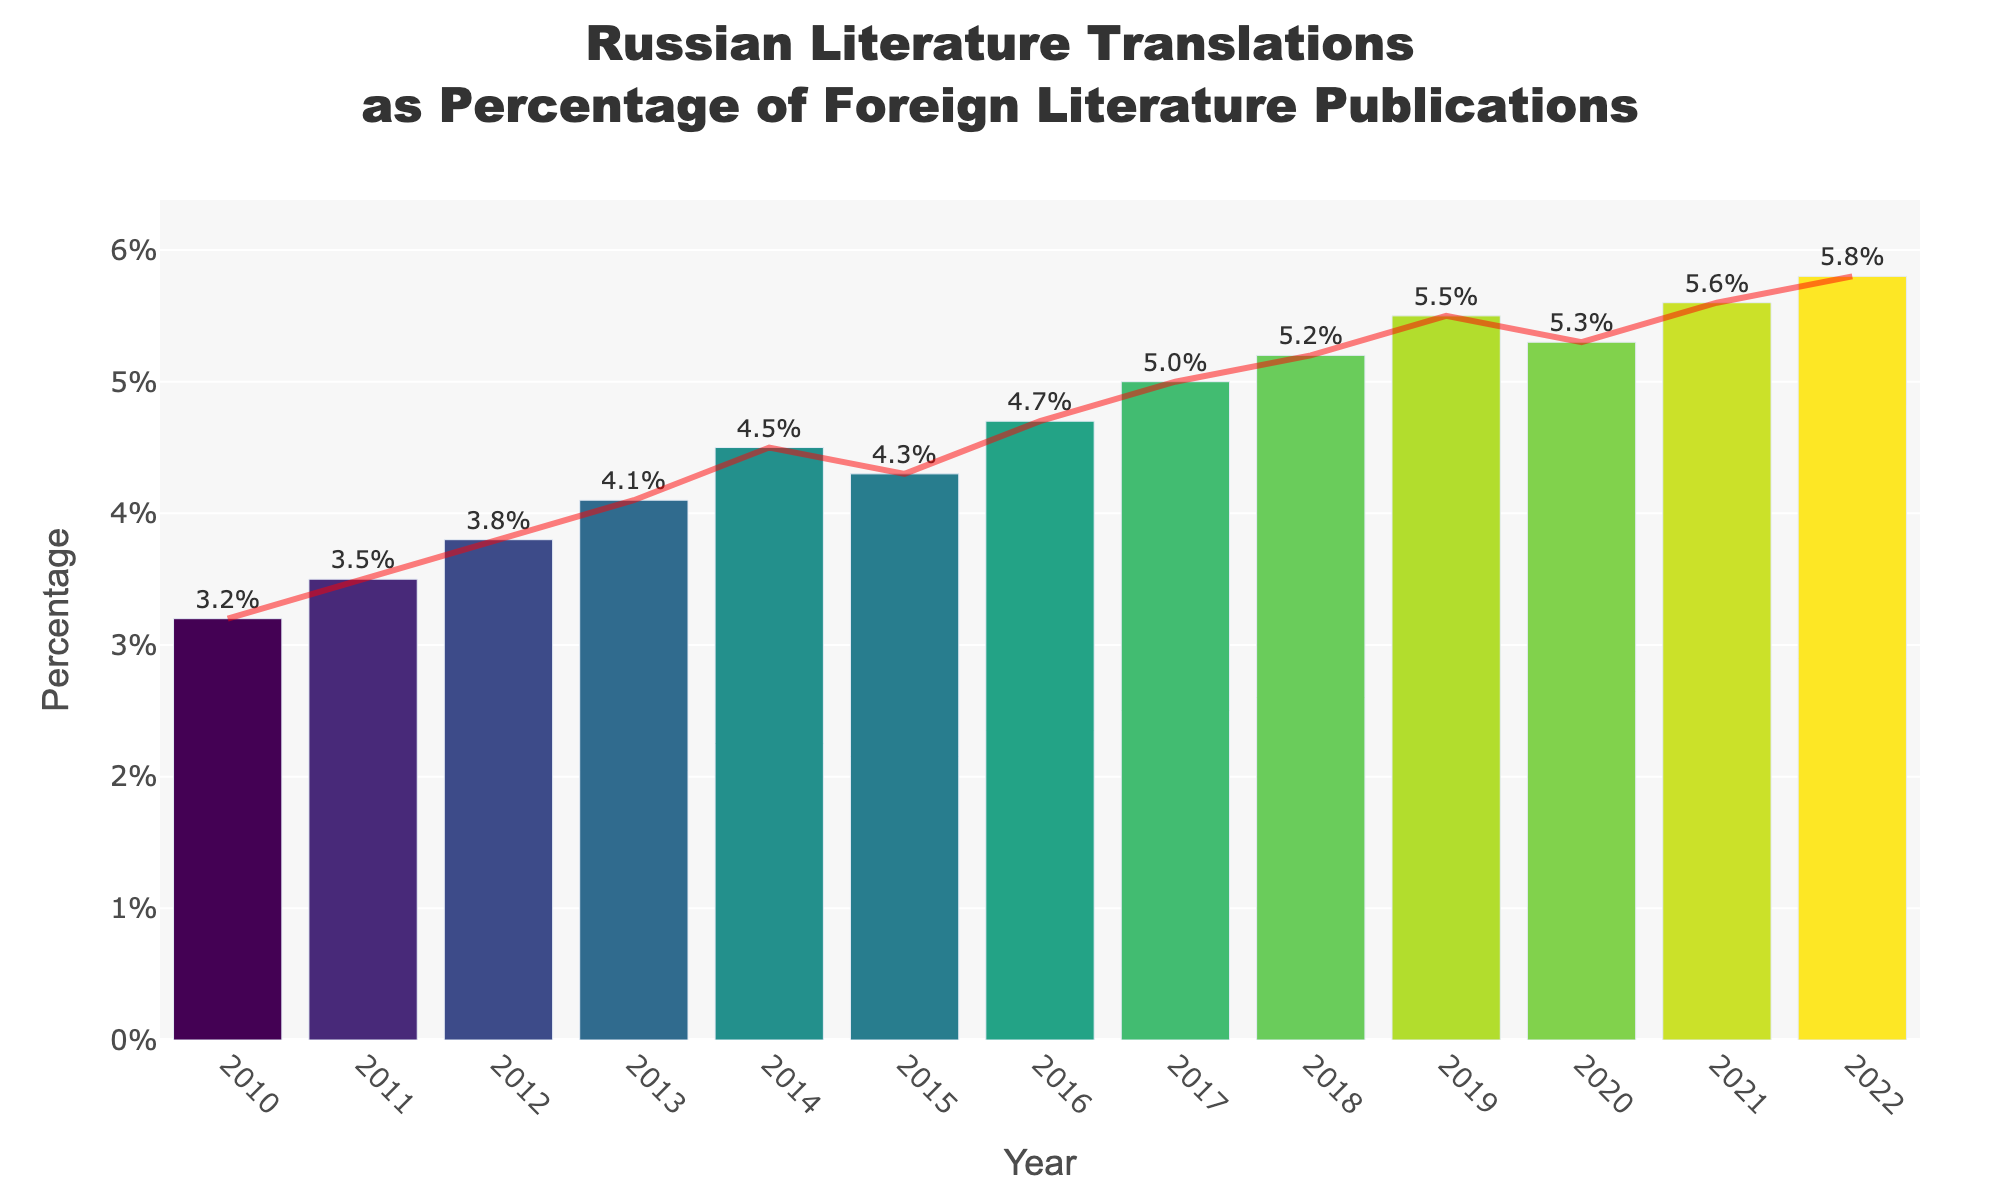What was the percentage of Russian literature translations in 2015? Locate the bar representing the year 2015 in the chart. The percentage value is displayed at the top of the bar.
Answer: 4.3% Which year had the highest percentage of Russian literature translations? Identify the tallest bar in the chart. The year corresponding to this bar represents the highest percentage.
Answer: 2022 Did the percentage of Russian literature translations increase or decrease from 2014 to 2015? Compare the heights of the bars for 2014 and 2015. The bar for 2014 is slightly lower than the bar for 2015, indicating an increase.
Answer: Increase What is the difference in percentages of Russian literature translations between 2010 and 2022? Locate the bars for 2010 and 2022. Subtract the 2010 percentage (3.2%) from the 2022 percentage (5.8%).
Answer: 2.6% Which year had a percentage of Russian literature translations closest to 5%? Find the bar whose label is closest to 5%. The bar for the year 2017 has a percentage of 5.0%, which is exactly 5%.
Answer: 2017 What is the average percentage of Russian literature translations from 2010 to 2015? Sum the percentages from 2010 to 2015 (3.2% + 3.5% + 3.8% + 4.1% + 4.5% + 4.3%) and divide by the number of years (6). (3.2 + 3.5 + 3.8 + 4.1 + 4.5 + 4.3) / 6 = 3.9%
Answer: 3.9% How did the trend line change from 2018 to 2020? Observe the trend line between the bars for 2018 and 2020. It increases from 2018 to 2019 but slightly decreases from 2019 to 2020.
Answer: Increase then decrease What is the percentage change in Russian literature translations from 2016 to 2018? Note the percentages for 2016 (4.7%) and 2018 (5.2%). Calculate the percentage change: ((5.2 - 4.7) / 4.7) * 100%. ((5.2 - 4.7) / 4.7) * 100 = 10.64%
Answer: 10.64% Which two consecutive years had the smallest increase in percentage of Russian literature translations? Compare the increases between consecutive pairs of years and find the smallest increase. The smallest increase occurs between 2020 (5.3%) and 2021 (5.6%), which is 0.3%.
Answer: 2020-2021 